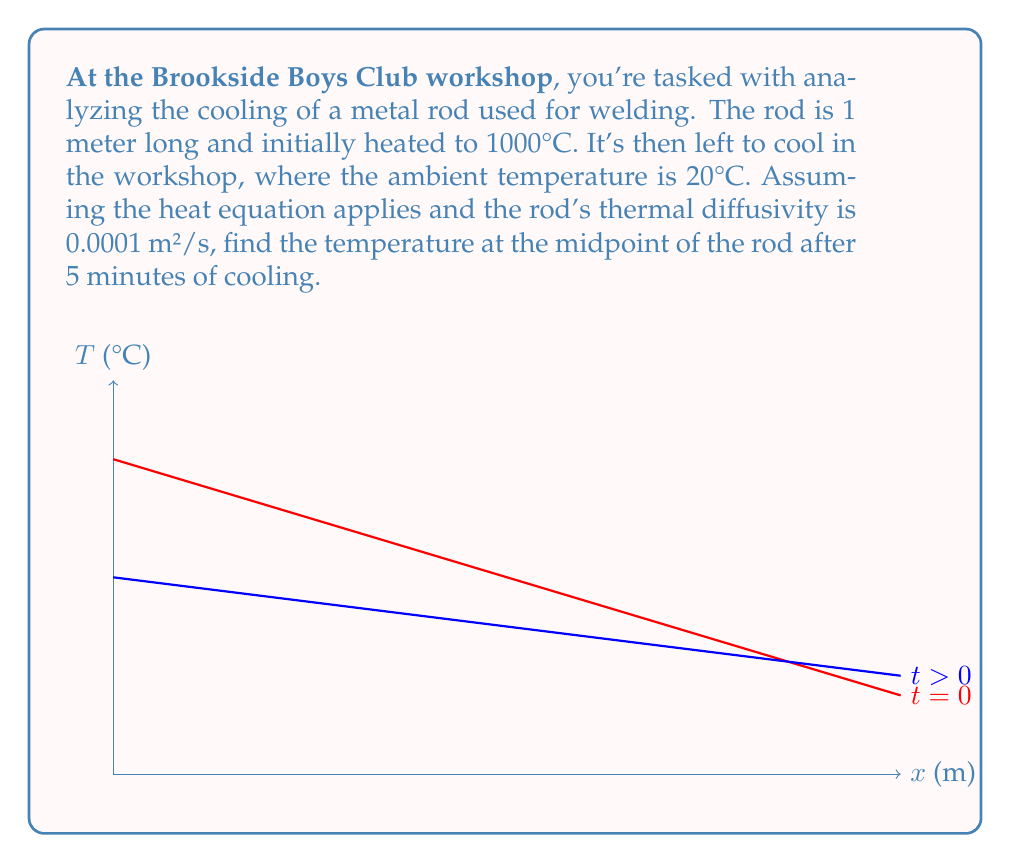What is the answer to this math problem? Let's approach this step-by-step:

1) The heat equation in one dimension is:

   $$\frac{\partial T}{\partial t} = \alpha \frac{\partial^2 T}{\partial x^2}$$

   where $T$ is temperature, $t$ is time, $x$ is position, and $\alpha$ is thermal diffusivity.

2) Given:
   - Rod length $L = 1$ m
   - Initial temperature $T_0 = 1000°C$
   - Ambient temperature $T_a = 20°C$
   - Thermal diffusivity $\alpha = 0.0001$ m²/s
   - Time $t = 5$ minutes = 300 s
   - We need to find $T(0.5, 300)$

3) The solution to this problem is given by the Fourier series:

   $$T(x,t) = T_a + \sum_{n=1}^{\infty} B_n \sin(\frac{n\pi x}{L}) e^{-\alpha (\frac{n\pi}{L})^2 t}$$

   where $B_n = \frac{2}{L} \int_0^L (T_0 - T_a) \sin(\frac{n\pi x}{L}) dx$

4) Calculating $B_n$:
   $$B_n = \frac{2(T_0 - T_a)}{n\pi} (1 - \cos(n\pi)) = \frac{2(1000 - 20)}{n\pi} (1 - \cos(n\pi))$$

5) For odd $n$, $B_n = \frac{1960}{n\pi}$; for even $n$, $B_n = 0$

6) Substituting into the series and evaluating at $x = 0.5$ and $t = 300$:

   $$T(0.5, 300) = 20 + \sum_{n=1,3,5,...}^{\infty} \frac{1960}{n\pi} \sin(\frac{n\pi}{2}) e^{-0.0001 (n\pi)^2 300}$$

7) The series converges quickly. Taking the first few terms:

   $$T(0.5, 300) \approx 20 + 624.5 \cdot 1 \cdot e^{-0.2958} + 208.2 \cdot (-1) \cdot e^{-2.6622} + ...$$

8) Calculating:
   $$T(0.5, 300) \approx 20 + 462.7 - 15.9 + ... \approx 466.8°C$$
Answer: 466.8°C 